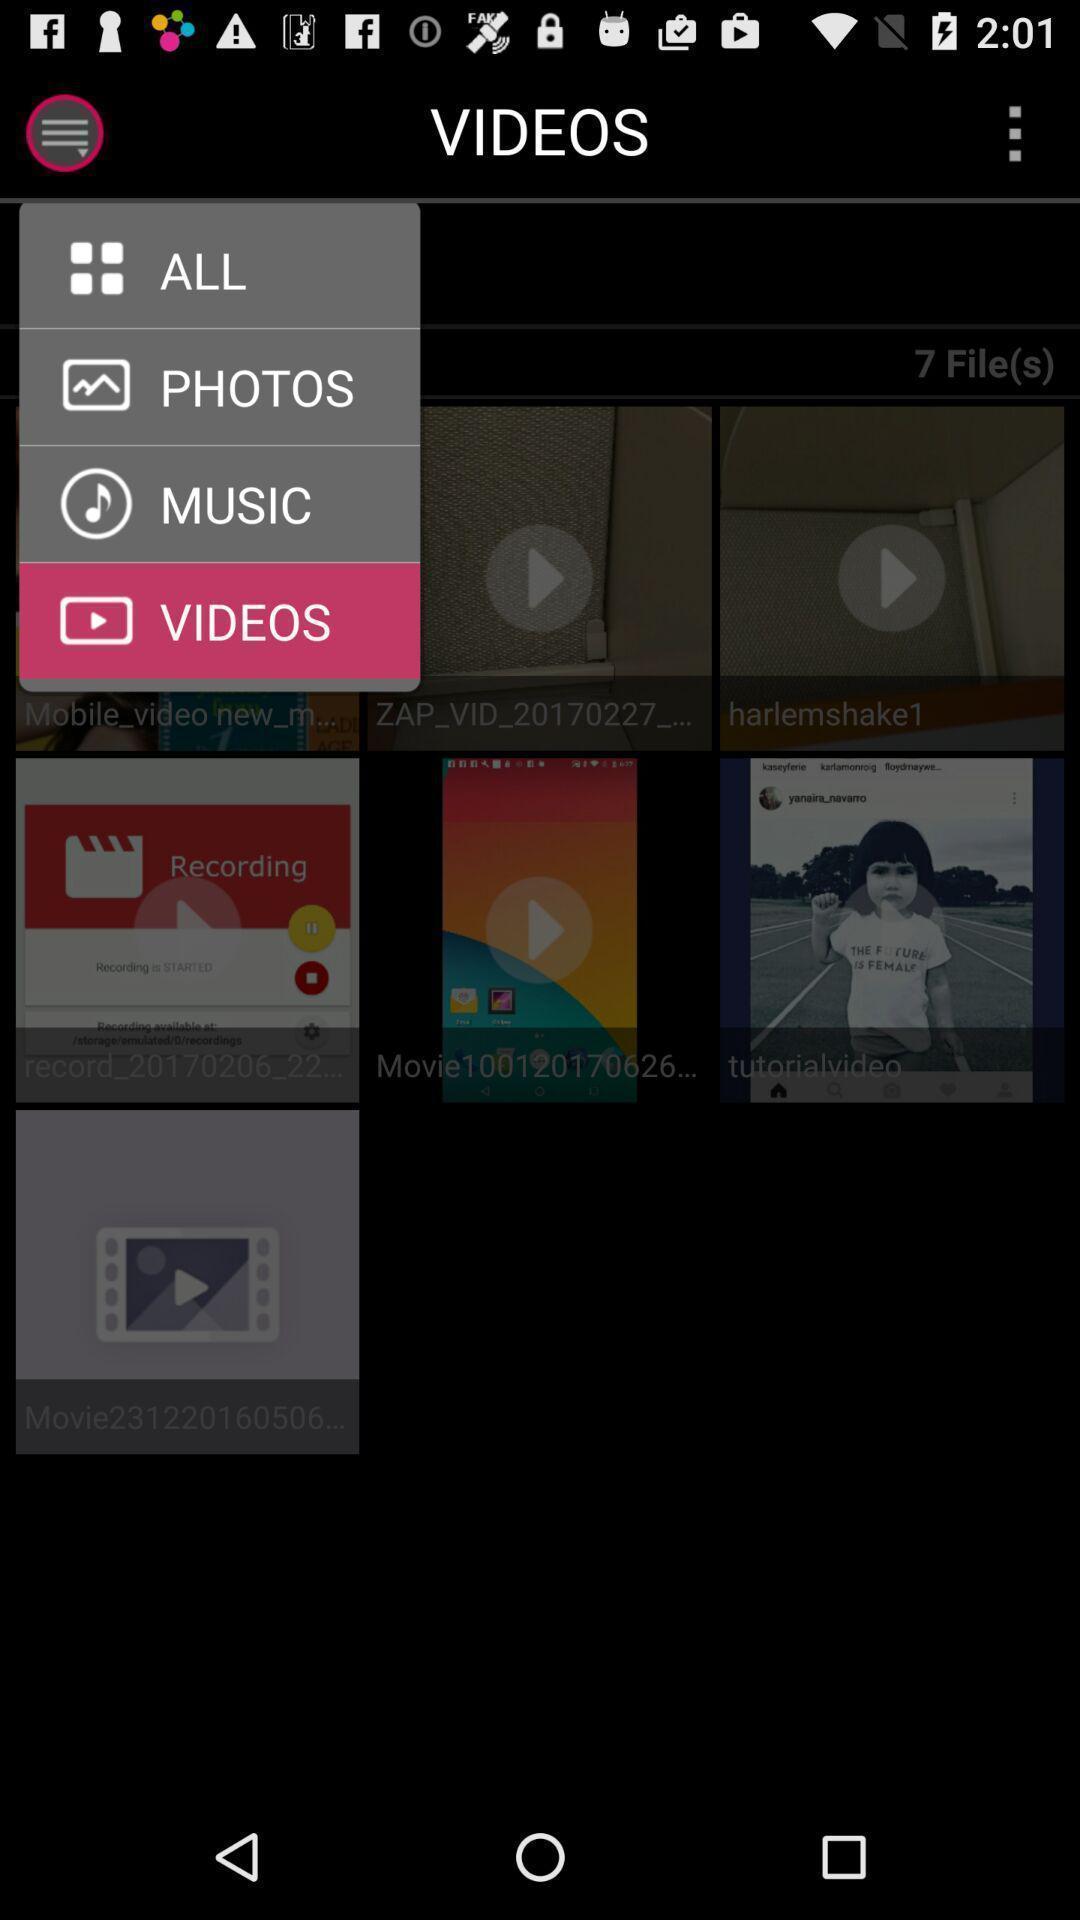Provide a textual representation of this image. Page displaying with menu and option videos in application. 